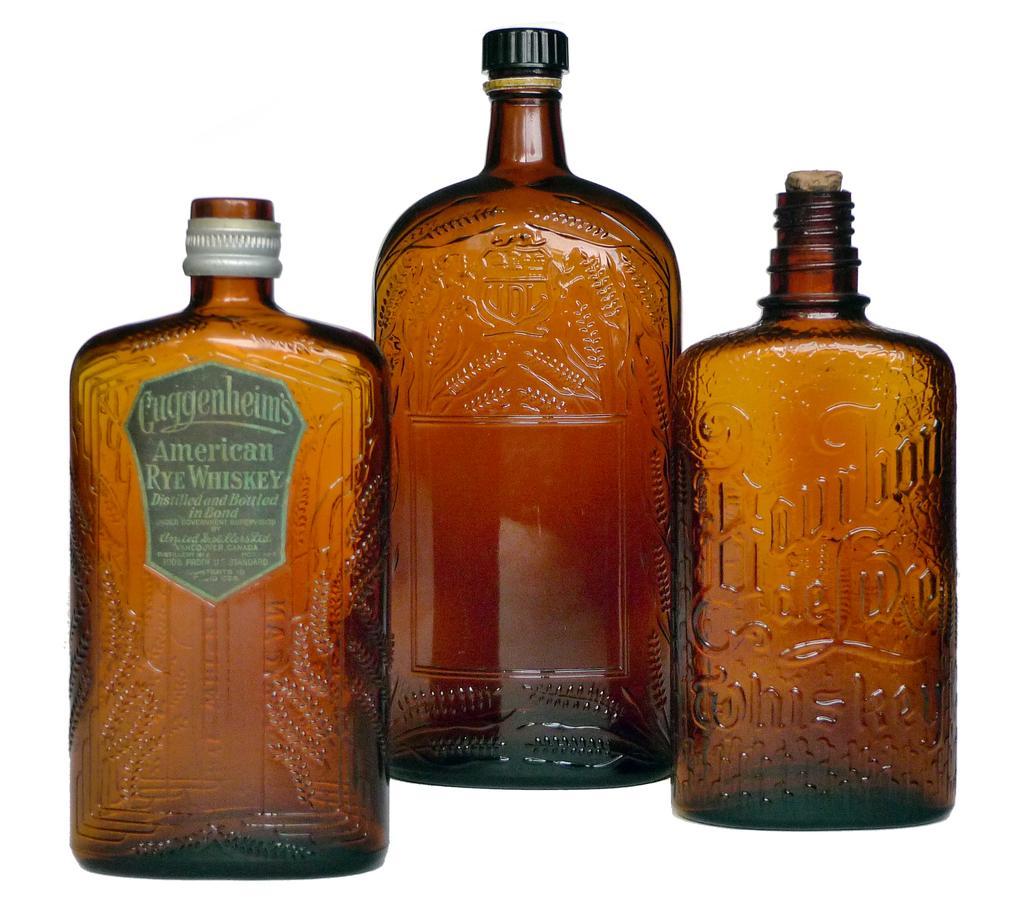How would you summarize this image in a sentence or two? There are three glass bottles and the background is white in color. 